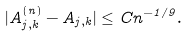<formula> <loc_0><loc_0><loc_500><loc_500>| A ^ { ( n ) } _ { j , k } - A _ { j , k } | \leq C n ^ { - 1 / 9 } .</formula> 